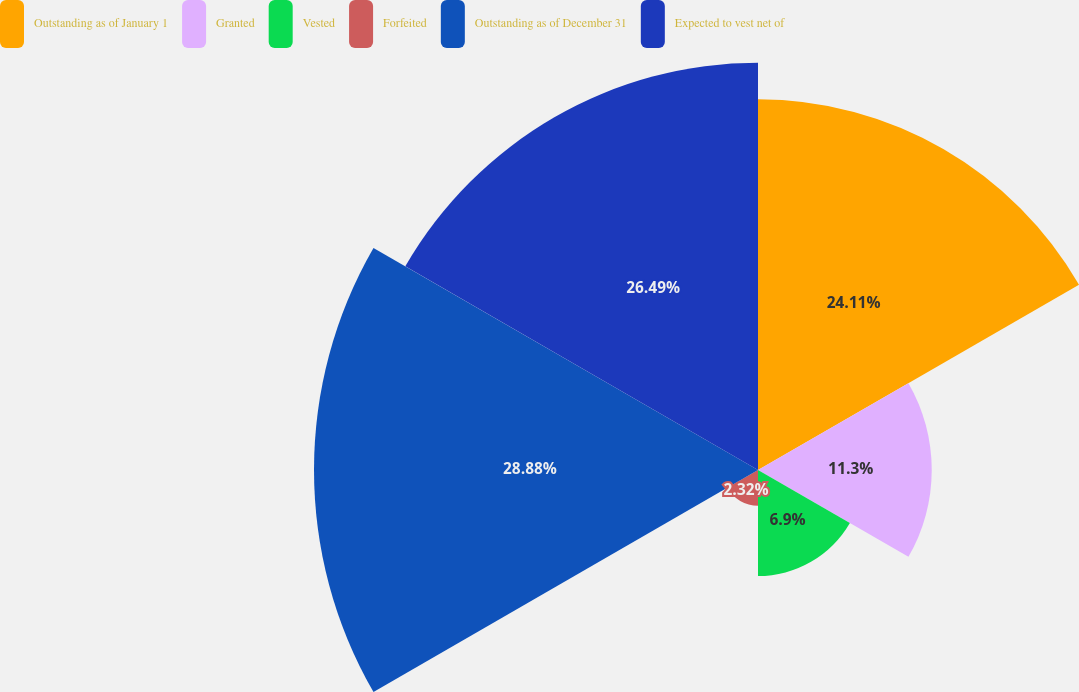Convert chart. <chart><loc_0><loc_0><loc_500><loc_500><pie_chart><fcel>Outstanding as of January 1<fcel>Granted<fcel>Vested<fcel>Forfeited<fcel>Outstanding as of December 31<fcel>Expected to vest net of<nl><fcel>24.11%<fcel>11.3%<fcel>6.9%<fcel>2.32%<fcel>28.88%<fcel>26.49%<nl></chart> 